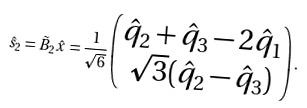<formula> <loc_0><loc_0><loc_500><loc_500>\hat { s } _ { 2 } = \tilde { B } _ { 2 } \hat { x } = \frac { 1 } { \sqrt { 6 } } \begin{pmatrix} \hat { q } _ { 2 } + \hat { q } _ { 3 } - 2 \hat { q } _ { 1 } \\ \sqrt { 3 } ( \hat { q } _ { 2 } - \hat { q } _ { 3 } ) \\ \end{pmatrix} .</formula> 